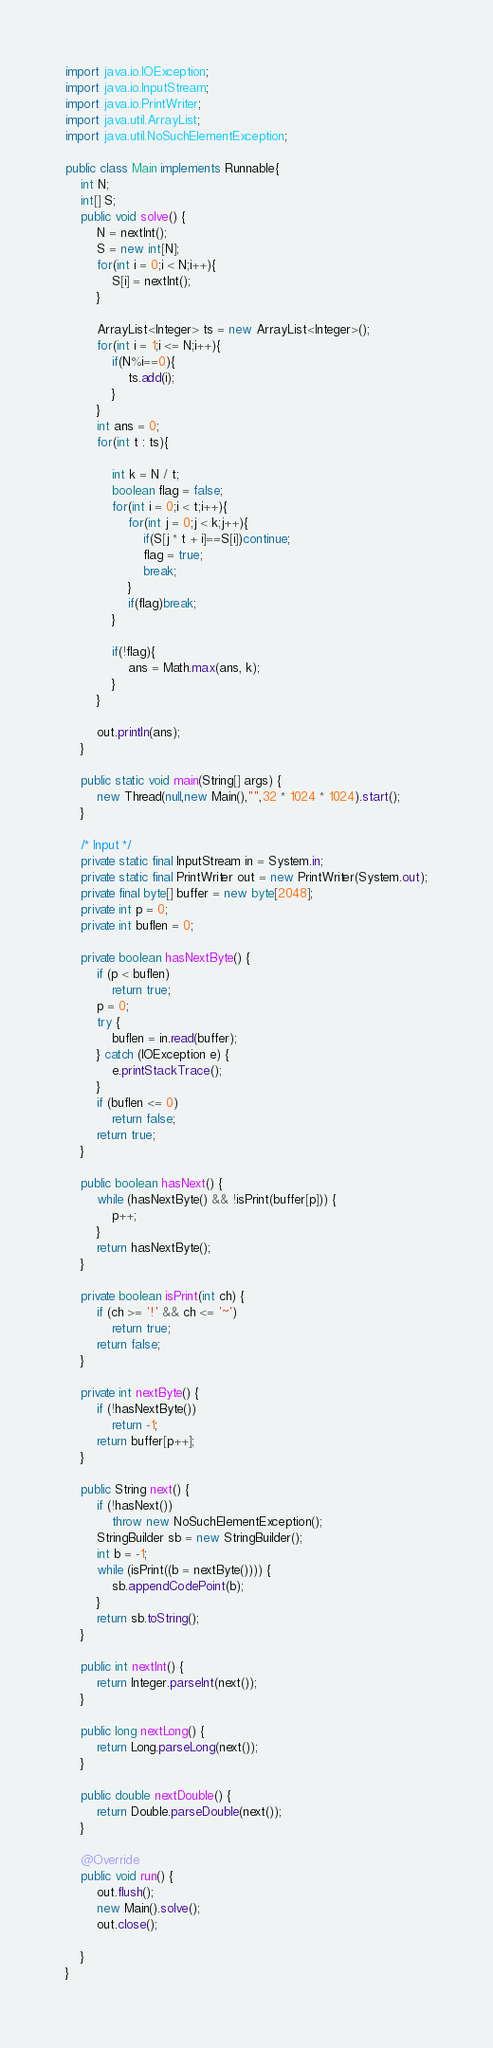<code> <loc_0><loc_0><loc_500><loc_500><_Java_>import java.io.IOException;
import java.io.InputStream;
import java.io.PrintWriter;
import java.util.ArrayList;
import java.util.NoSuchElementException;

public class Main implements Runnable{
	int N;
	int[] S;
	public void solve() {
		N = nextInt();
		S = new int[N];
		for(int i = 0;i < N;i++){
			S[i] = nextInt();
		}

		ArrayList<Integer> ts = new ArrayList<Integer>();
		for(int i = 1;i <= N;i++){
			if(N%i==0){
				ts.add(i);
			}
		}
		int ans = 0;
		for(int t : ts){

			int k = N / t;
			boolean flag = false;
			for(int i = 0;i < t;i++){
				for(int j = 0;j < k;j++){
					if(S[j * t + i]==S[i])continue;
					flag = true;
					break;
				}
				if(flag)break;
			}

			if(!flag){
				ans = Math.max(ans, k);
			}
		}

		out.println(ans);
	}

	public static void main(String[] args) {
		new Thread(null,new Main(),"",32 * 1024 * 1024).start();
	}

	/* Input */
	private static final InputStream in = System.in;
	private static final PrintWriter out = new PrintWriter(System.out);
	private final byte[] buffer = new byte[2048];
	private int p = 0;
	private int buflen = 0;

	private boolean hasNextByte() {
		if (p < buflen)
			return true;
		p = 0;
		try {
			buflen = in.read(buffer);
		} catch (IOException e) {
			e.printStackTrace();
		}
		if (buflen <= 0)
			return false;
		return true;
	}

	public boolean hasNext() {
		while (hasNextByte() && !isPrint(buffer[p])) {
			p++;
		}
		return hasNextByte();
	}

	private boolean isPrint(int ch) {
		if (ch >= '!' && ch <= '~')
			return true;
		return false;
	}

	private int nextByte() {
		if (!hasNextByte())
			return -1;
		return buffer[p++];
	}

	public String next() {
		if (!hasNext())
			throw new NoSuchElementException();
		StringBuilder sb = new StringBuilder();
		int b = -1;
		while (isPrint((b = nextByte()))) {
			sb.appendCodePoint(b);
		}
		return sb.toString();
	}

	public int nextInt() {
		return Integer.parseInt(next());
	}

	public long nextLong() {
		return Long.parseLong(next());
	}

	public double nextDouble() {
		return Double.parseDouble(next());
	}

	@Override
	public void run() {
		out.flush();
		new Main().solve();
		out.close();

	}
}</code> 